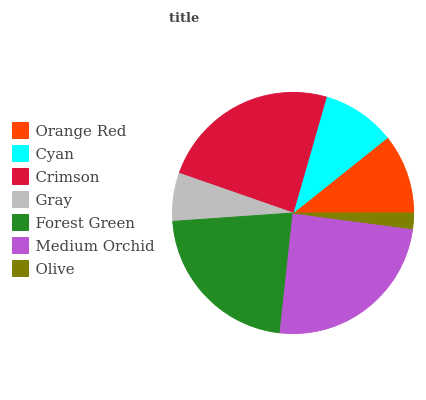Is Olive the minimum?
Answer yes or no. Yes. Is Medium Orchid the maximum?
Answer yes or no. Yes. Is Cyan the minimum?
Answer yes or no. No. Is Cyan the maximum?
Answer yes or no. No. Is Orange Red greater than Cyan?
Answer yes or no. Yes. Is Cyan less than Orange Red?
Answer yes or no. Yes. Is Cyan greater than Orange Red?
Answer yes or no. No. Is Orange Red less than Cyan?
Answer yes or no. No. Is Orange Red the high median?
Answer yes or no. Yes. Is Orange Red the low median?
Answer yes or no. Yes. Is Cyan the high median?
Answer yes or no. No. Is Gray the low median?
Answer yes or no. No. 